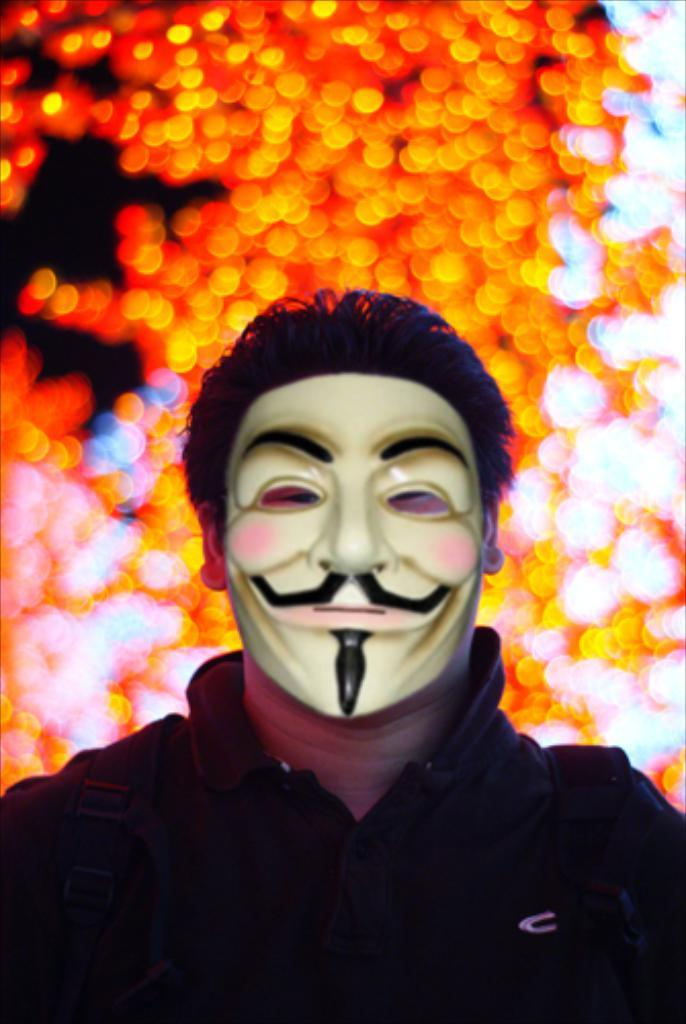What is the person in the image wearing on their face? The person in the image is wearing a mask. Can you describe the background of the image? The background of the image is blurred. What book is the person reading in the image? There is no book or reading activity present in the image. 